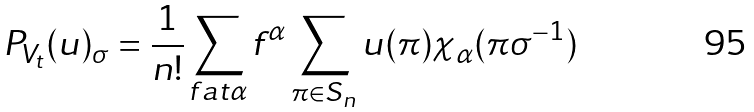Convert formula to latex. <formula><loc_0><loc_0><loc_500><loc_500>P _ { V _ { t } } ( u ) _ { \sigma } = \frac { 1 } { n ! } \sum _ { f a t \alpha } f ^ { \alpha } \sum _ { \pi \in S _ { n } } u ( \pi ) \chi _ { \alpha } ( \pi \sigma ^ { - 1 } )</formula> 